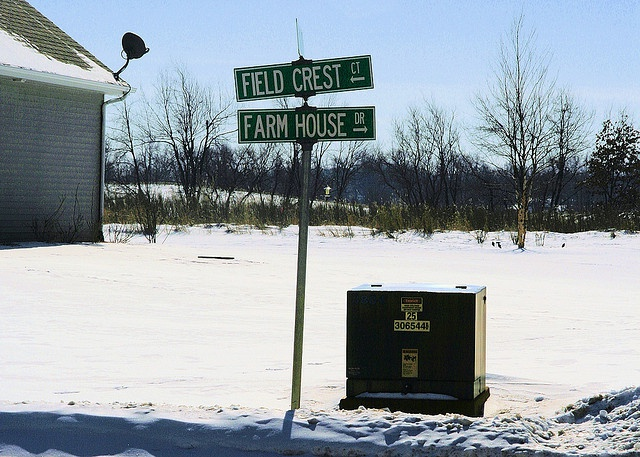Describe the objects in this image and their specific colors. I can see various objects in this image with different colors. 